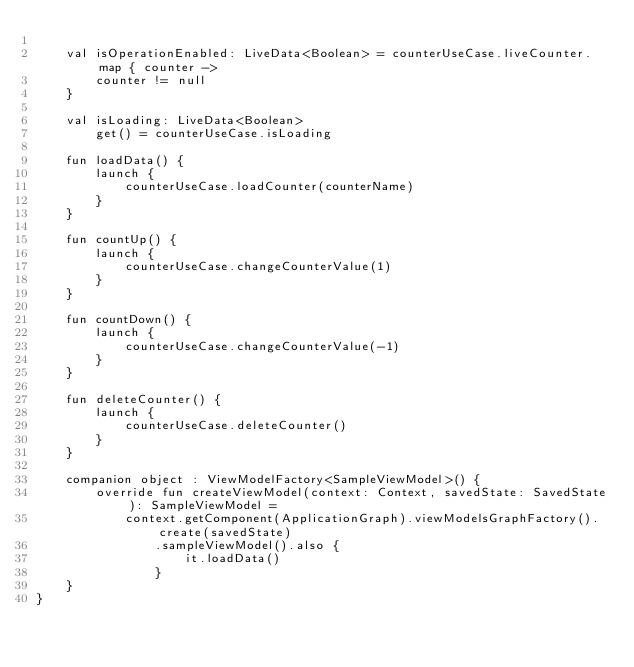<code> <loc_0><loc_0><loc_500><loc_500><_Kotlin_>
    val isOperationEnabled: LiveData<Boolean> = counterUseCase.liveCounter.map { counter ->
        counter != null
    }

    val isLoading: LiveData<Boolean>
        get() = counterUseCase.isLoading

    fun loadData() {
        launch {
            counterUseCase.loadCounter(counterName)
        }
    }

    fun countUp() {
        launch {
            counterUseCase.changeCounterValue(1)
        }
    }

    fun countDown() {
        launch {
            counterUseCase.changeCounterValue(-1)
        }
    }

    fun deleteCounter() {
        launch {
            counterUseCase.deleteCounter()
        }
    }

    companion object : ViewModelFactory<SampleViewModel>() {
        override fun createViewModel(context: Context, savedState: SavedState): SampleViewModel =
            context.getComponent(ApplicationGraph).viewModelsGraphFactory().create(savedState)
                .sampleViewModel().also {
                    it.loadData()
                }
    }
}
</code> 